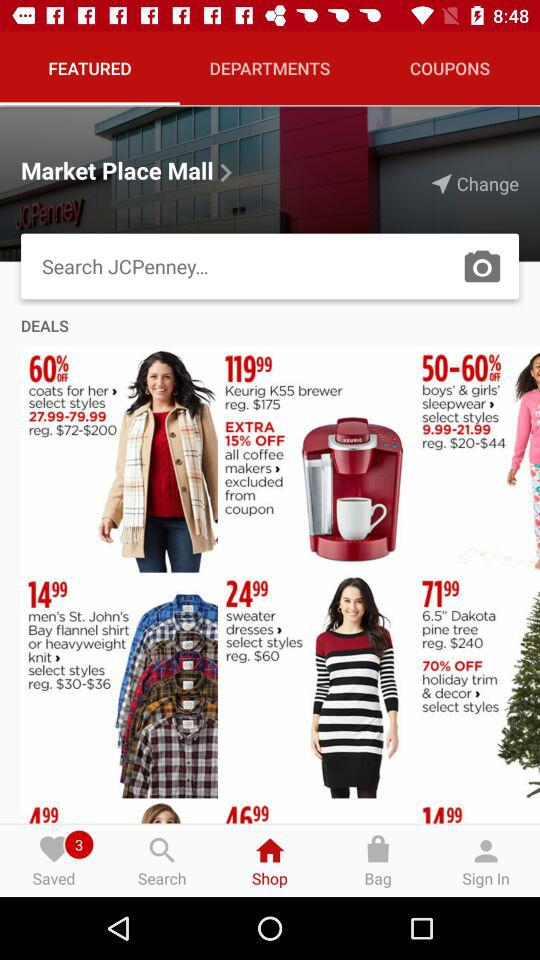How much is the discounted range on "boys' and girls' sleepwear"? The discounted range on "boys' and girls' sleepwear" in percentage is 50–60%. 